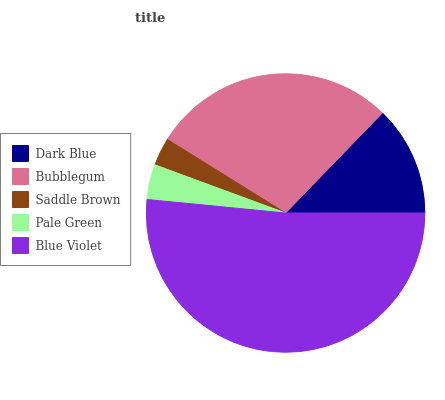Is Saddle Brown the minimum?
Answer yes or no. Yes. Is Blue Violet the maximum?
Answer yes or no. Yes. Is Bubblegum the minimum?
Answer yes or no. No. Is Bubblegum the maximum?
Answer yes or no. No. Is Bubblegum greater than Dark Blue?
Answer yes or no. Yes. Is Dark Blue less than Bubblegum?
Answer yes or no. Yes. Is Dark Blue greater than Bubblegum?
Answer yes or no. No. Is Bubblegum less than Dark Blue?
Answer yes or no. No. Is Dark Blue the high median?
Answer yes or no. Yes. Is Dark Blue the low median?
Answer yes or no. Yes. Is Pale Green the high median?
Answer yes or no. No. Is Blue Violet the low median?
Answer yes or no. No. 